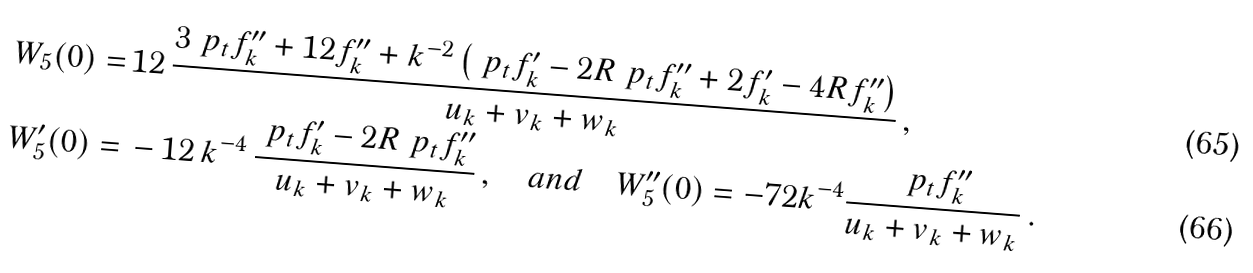Convert formula to latex. <formula><loc_0><loc_0><loc_500><loc_500>W _ { 5 } ( 0 ) = & \, 1 2 \, \frac { 3 \ p _ { t } f ^ { \prime \prime } _ { k } + 1 2 f ^ { \prime \prime } _ { k } + k ^ { - 2 } \left ( \ p _ { t } f ^ { \prime } _ { k } - 2 R \ p _ { t } f ^ { \prime \prime } _ { k } + 2 f ^ { \prime } _ { k } - 4 R f ^ { \prime \prime } _ { k } \right ) } { u _ { k } + v _ { k } + w _ { k } } \, , \\ W _ { 5 } ^ { \prime } ( 0 ) = & \, - 1 2 \, k ^ { - 4 } \, \frac { \ p _ { t } f ^ { \prime } _ { k } - 2 R \ p _ { t } f ^ { \prime \prime } _ { k } } { u _ { k } + v _ { k } + w _ { k } } \, , \quad a n d \quad W _ { 5 } ^ { \prime \prime } ( 0 ) = - 7 2 k ^ { - 4 } \frac { \ p _ { t } f _ { k } ^ { \prime \prime } } { u _ { k } + v _ { k } + w _ { k } } \, .</formula> 